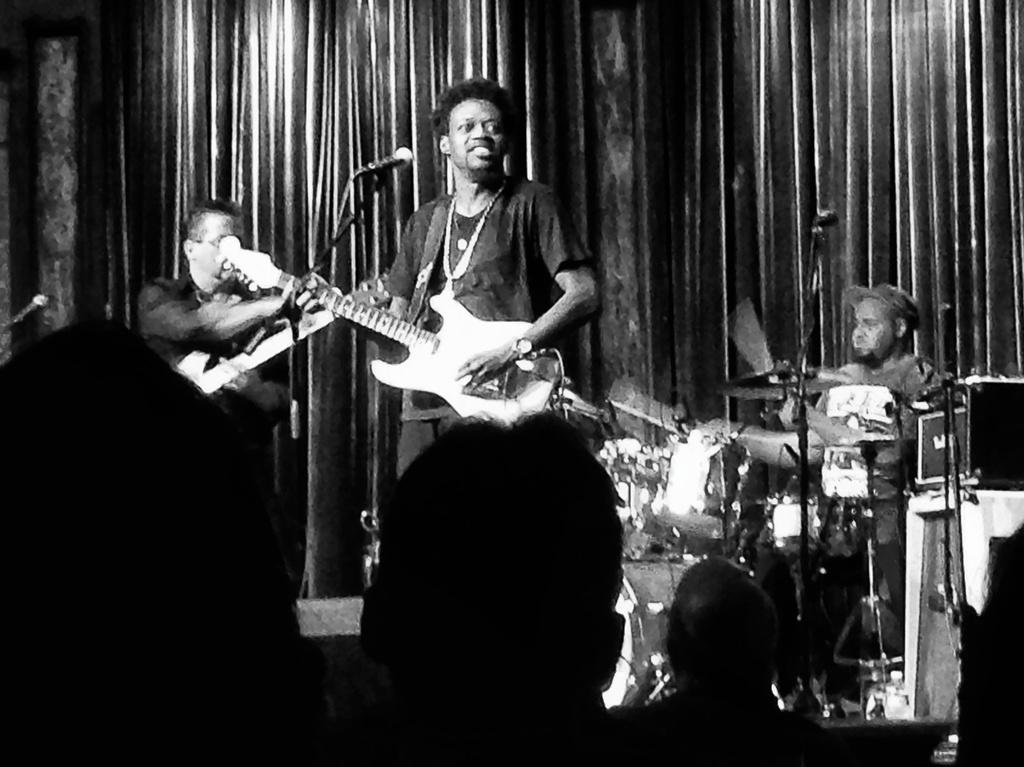What are the musicians in the image doing? There is a man standing and playing a guitar, and another man seated and playing drums in the image. What instrument is the third man holding in the image? The third man is holding a guitar in the image. Who is watching the musicians perform? There are people (audience) watching the musicians in the image. What type of bear can be seen playing the drums in the image? There is no bear present in the image; the drummer is a man. What educational level is required to play the guitar in the image? The image does not provide information about the musicians' educational backgrounds, so it cannot be determined from the image. 